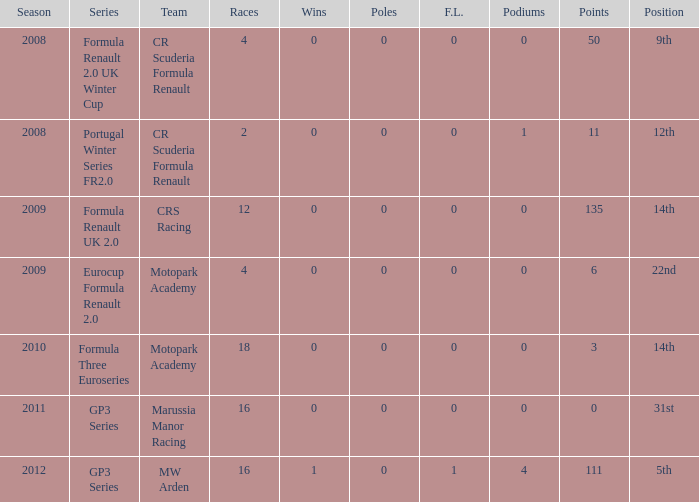What is the point total for marussia manor racing? 1.0. 